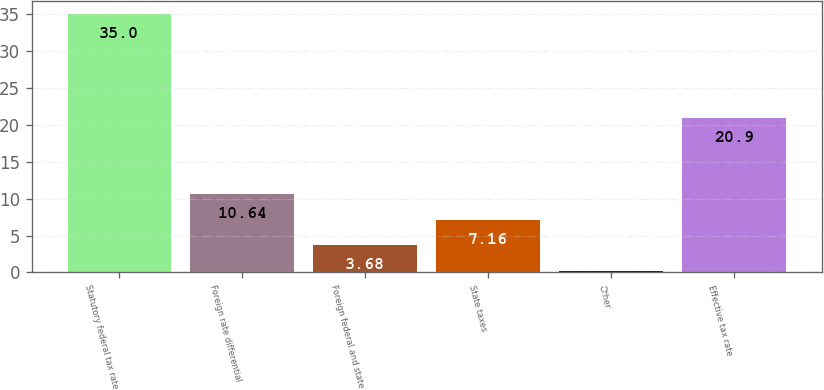<chart> <loc_0><loc_0><loc_500><loc_500><bar_chart><fcel>Statutory federal tax rate<fcel>Foreign rate differential<fcel>Foreign federal and state<fcel>State taxes<fcel>Other<fcel>Effective tax rate<nl><fcel>35<fcel>10.64<fcel>3.68<fcel>7.16<fcel>0.2<fcel>20.9<nl></chart> 